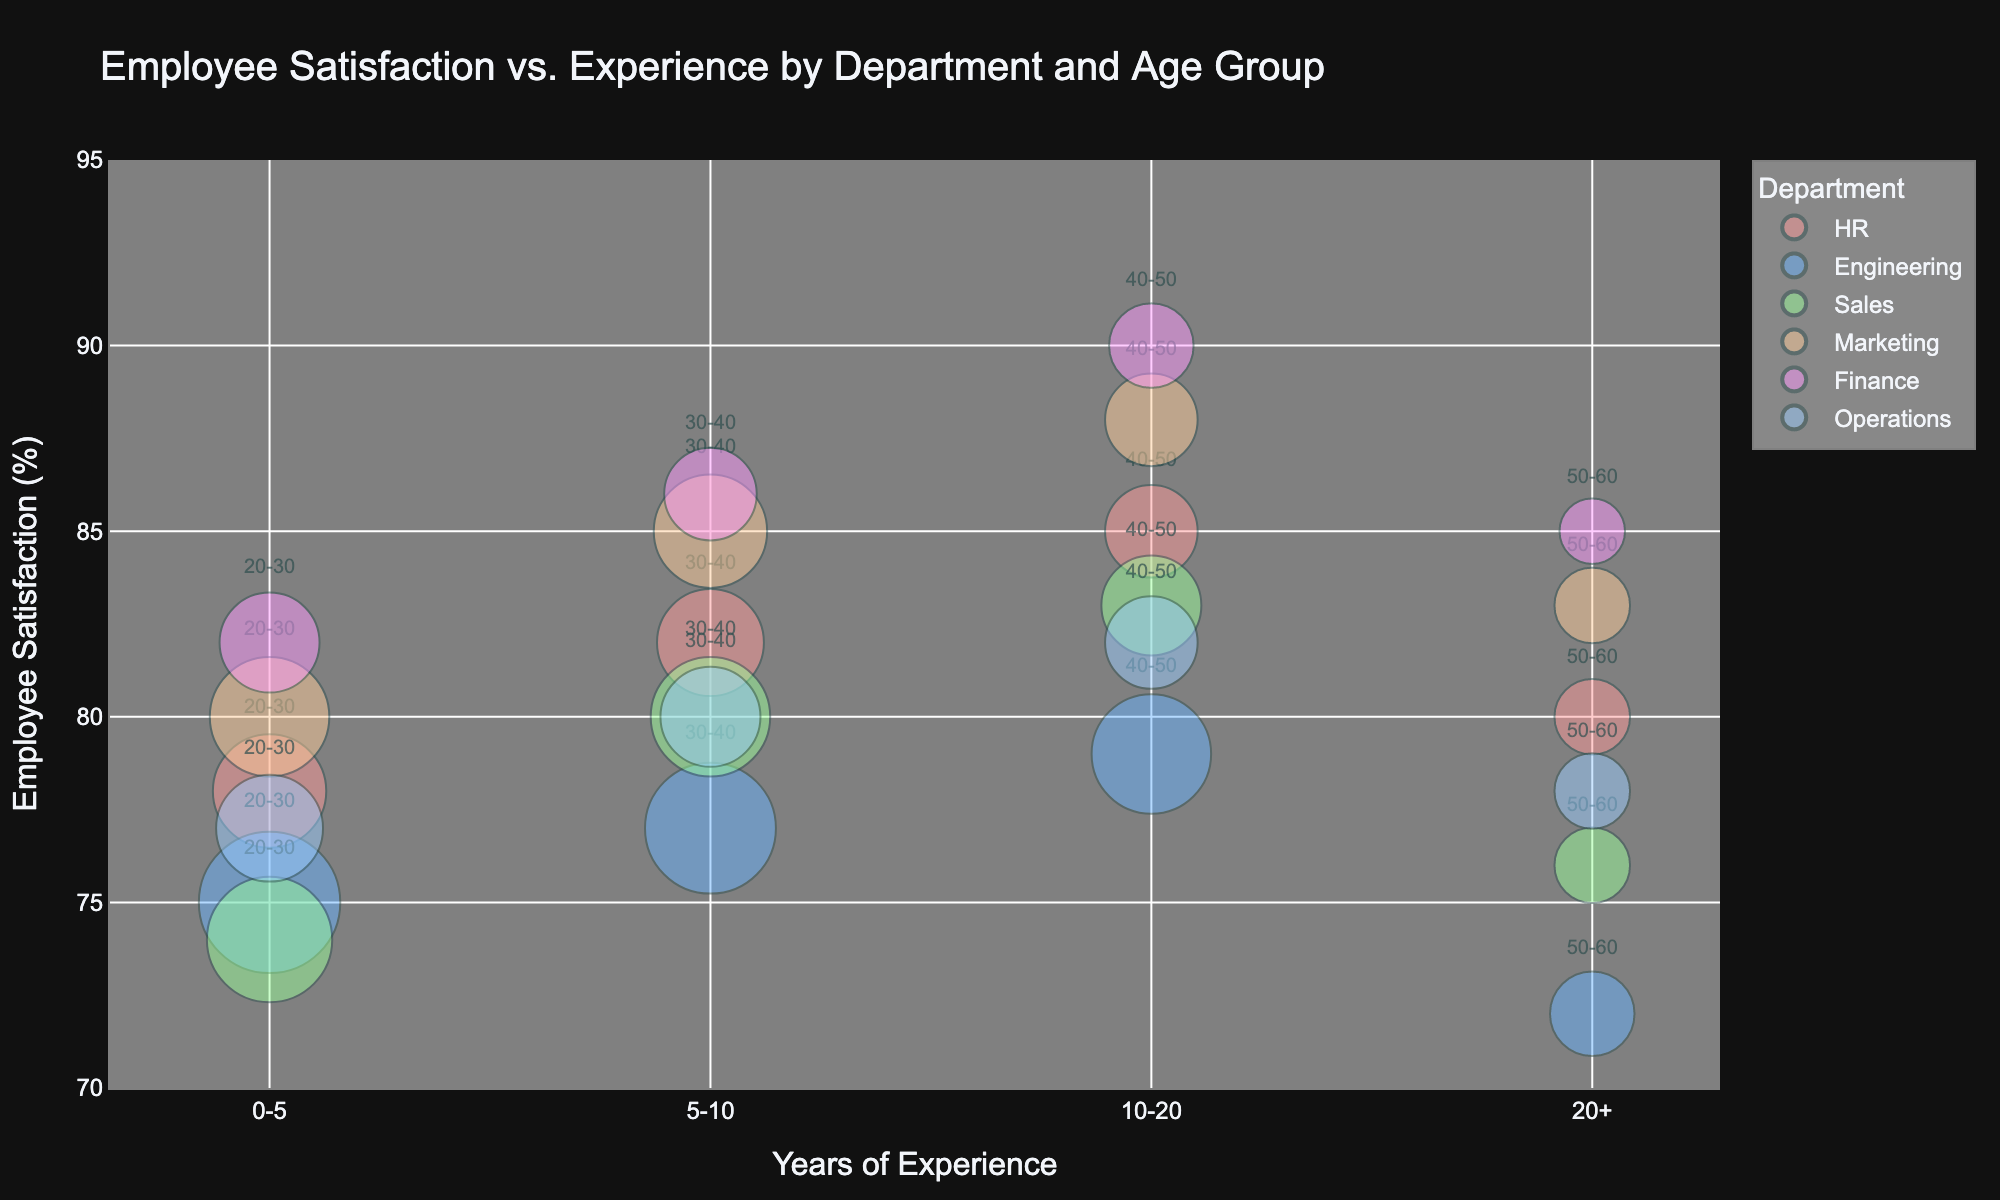What is the average employee satisfaction in the HR department? There are four data points for the HR department: 78, 82, 85, and 80. The average is calculated as (78 + 82 + 85 + 80) / 4 = 81.25.
Answer: 81.25 Which department has the highest level of employee satisfaction? The highest employee satisfaction in any department is 90, which is in the Finance department for the 40-50 age group with 10-20 years of experience.
Answer: Finance What is the title of the bubble chart? The title of the bubble chart is listed at the top. It says "Employee Satisfaction vs. Experience by Department and Age Group".
Answer: Employee Satisfaction vs. Experience by Department and Age Group How does employee satisfaction in Engineering compare to that in Sales for employees aged 40-50 with 10-20 years of experience? For Engineering, employee satisfaction is 79, and for Sales, it is 83. Comparing these two numbers, employee satisfaction in Sales is higher.
Answer: Sales What is the range of the y-axis? The y-axis represents Employee Satisfaction and ranges from 70 to 95. This can be seen on the y-axis labels.
Answer: 70 to 95 Which age group in the Marketing department has the highest employee satisfaction? For Marketing, the data points for employee satisfaction by age group are: 80 (20-30), 85 (30-40), 88 (40-50), 83 (50-60). The highest satisfaction is 88 in the 40-50 age group.
Answer: 40-50 How many data points are represented in the bubble chart? Each department and age group combination represents a unique data point. There are six departments and four age groups each, totaling 24 data points.
Answer: 24 What is the average satisfaction level for employees with 20+ years of experience across all departments? The satisfaction levels for employees with 20+ years of experience are as follows: HR (80), Engineering (72), Sales (76), Marketing (83), Finance (85), Operations (78). The average is (80 + 72 + 76 + 83 + 85 + 78) / 6 = 79.
Answer: 79 Which department has the largest bubble for the 20-30 age group? For the 20-30 age group, the number of employees is listed, and the largest bubble represents the Engineering department with 70 employees.
Answer: Engineering 